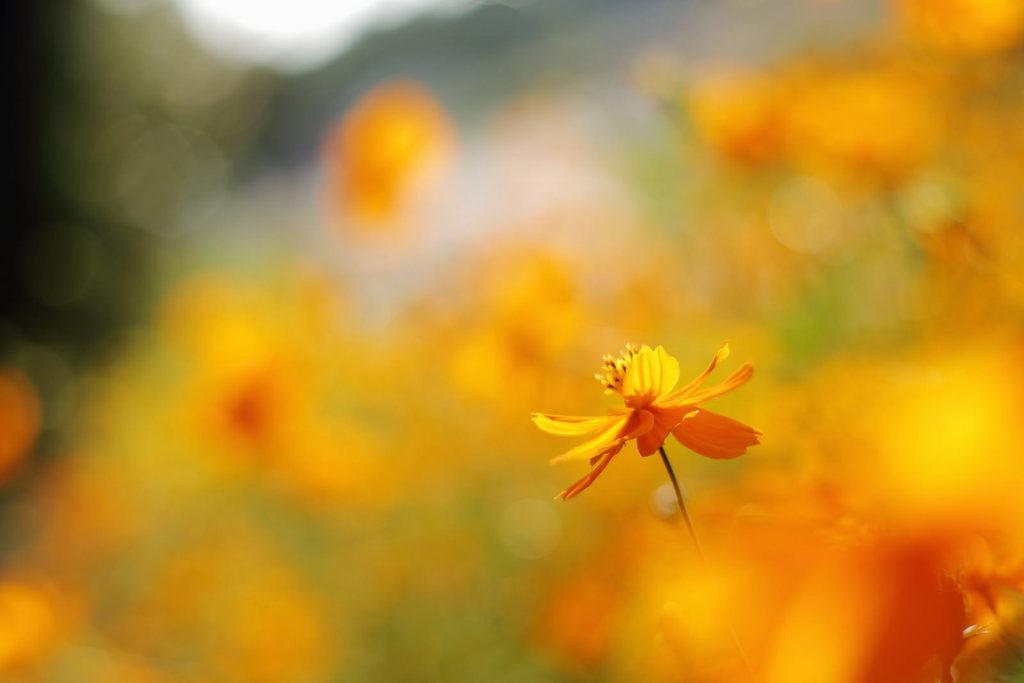What type of flower is in the image? There is an orange color flower in the image. What can be observed about the background of the image? The background of the image is orange and blurred. Is there a locket hanging from the stem of the flower in the image? No, there is no locket present in the image. Is the flower wearing a crown in the image? No, the flower is not wearing a crown in the image. 